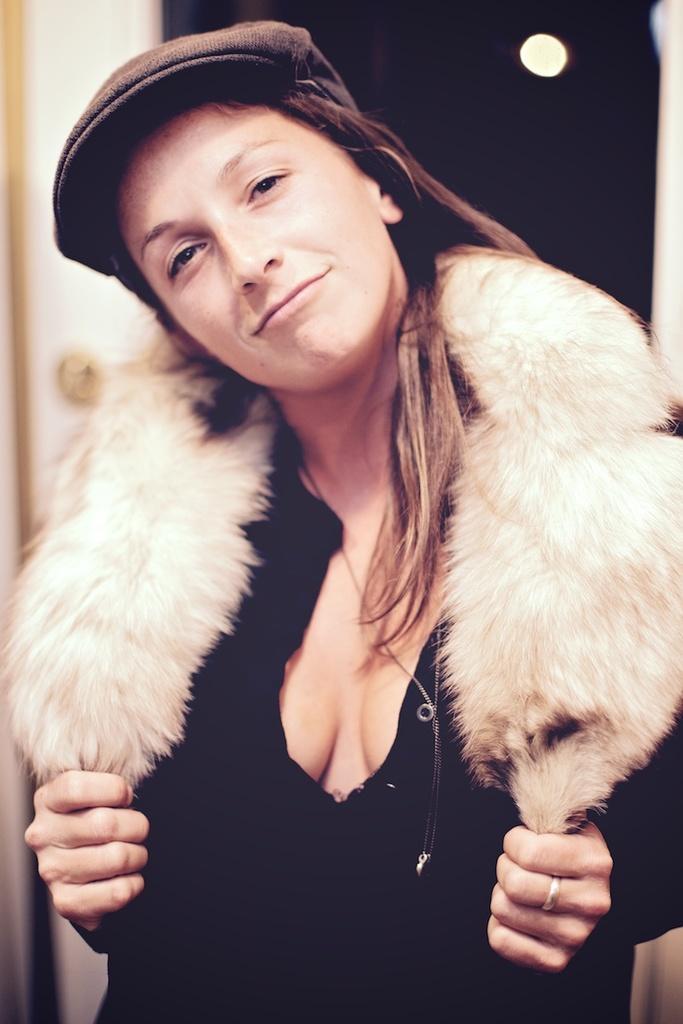Could you give a brief overview of what you see in this image? In this image in the front there is a woman having smile on her face. In the background there is a wall, which is white in colour and the woman is wearing a hat. 